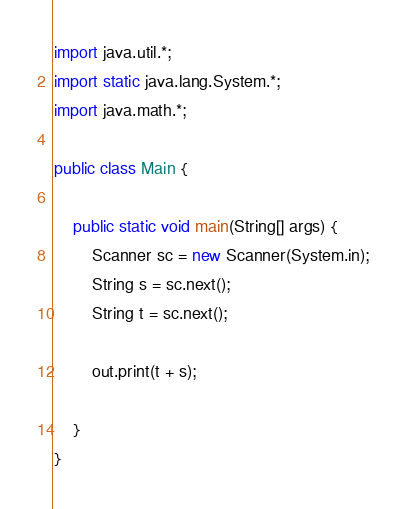<code> <loc_0><loc_0><loc_500><loc_500><_Java_>import java.util.*;
import static java.lang.System.*;
import java.math.*;

public class Main {

	public static void main(String[] args) {
		Scanner sc = new Scanner(System.in);
		String s = sc.next();
		String t = sc.next();
		
		out.print(t + s);
		
	}
}</code> 